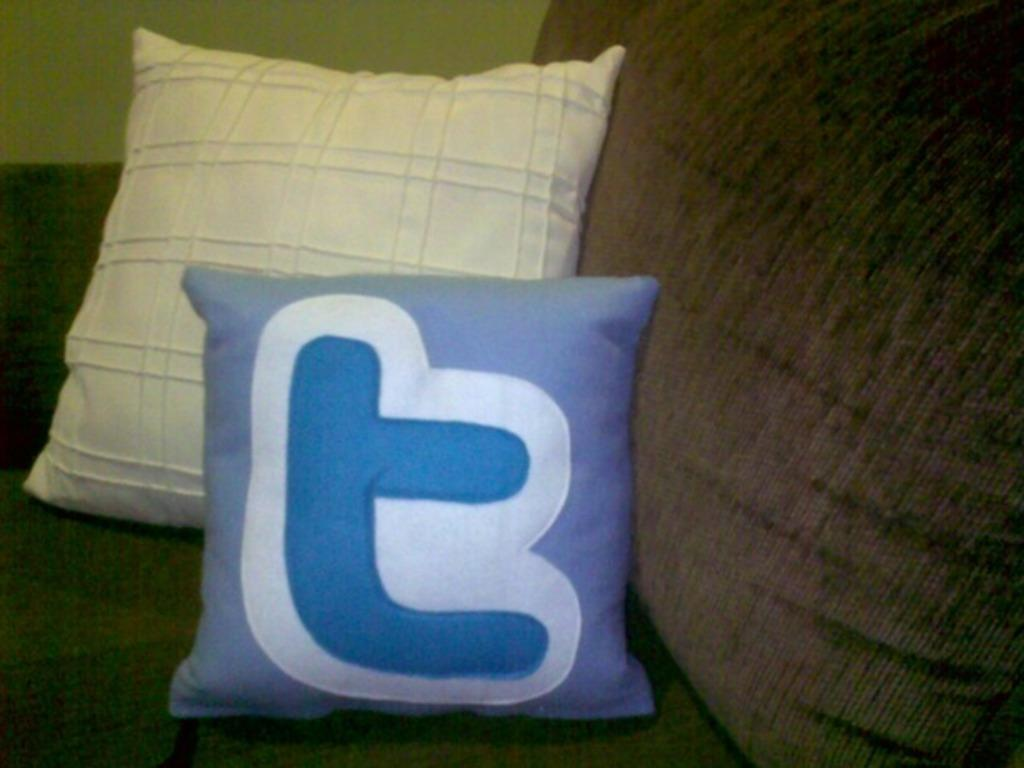What type of furniture is in the image? There is a couch in the image. What colors are the couch? The couch is brown and black in color. How many cushions are on the couch? There are two cushions on the couch. What colors are the cushions? The cushions are blue and white in color. What can be seen in the background of the image? There is a wall visible in the background of the image. How many cakes are being baked in the oven in the image? There is no oven or cakes present in the image; it only features a couch with cushions and a wall in the background. 